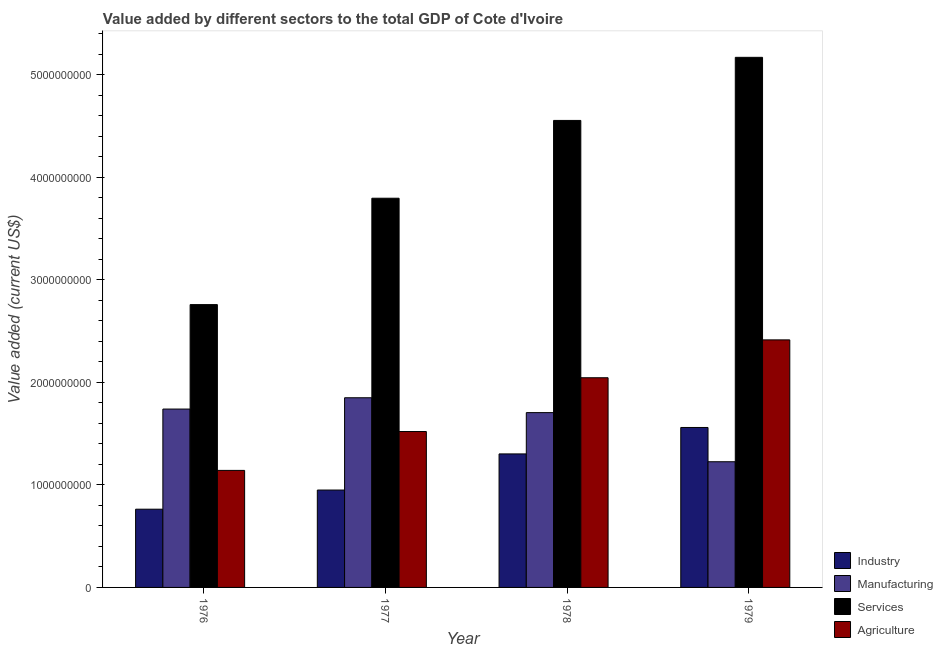How many groups of bars are there?
Your answer should be very brief. 4. How many bars are there on the 3rd tick from the left?
Provide a succinct answer. 4. How many bars are there on the 1st tick from the right?
Your response must be concise. 4. What is the label of the 3rd group of bars from the left?
Offer a terse response. 1978. In how many cases, is the number of bars for a given year not equal to the number of legend labels?
Make the answer very short. 0. What is the value added by services sector in 1978?
Your answer should be compact. 4.55e+09. Across all years, what is the maximum value added by industrial sector?
Offer a very short reply. 1.56e+09. Across all years, what is the minimum value added by manufacturing sector?
Provide a short and direct response. 1.23e+09. In which year was the value added by industrial sector maximum?
Offer a very short reply. 1979. In which year was the value added by industrial sector minimum?
Your answer should be very brief. 1976. What is the total value added by manufacturing sector in the graph?
Provide a succinct answer. 6.52e+09. What is the difference between the value added by industrial sector in 1978 and that in 1979?
Provide a short and direct response. -2.58e+08. What is the difference between the value added by services sector in 1976 and the value added by manufacturing sector in 1978?
Keep it short and to the point. -1.80e+09. What is the average value added by agricultural sector per year?
Give a very brief answer. 1.78e+09. In how many years, is the value added by agricultural sector greater than 4400000000 US$?
Keep it short and to the point. 0. What is the ratio of the value added by agricultural sector in 1976 to that in 1977?
Provide a short and direct response. 0.75. Is the difference between the value added by services sector in 1976 and 1979 greater than the difference between the value added by industrial sector in 1976 and 1979?
Give a very brief answer. No. What is the difference between the highest and the second highest value added by manufacturing sector?
Provide a succinct answer. 1.10e+08. What is the difference between the highest and the lowest value added by industrial sector?
Ensure brevity in your answer.  7.97e+08. In how many years, is the value added by agricultural sector greater than the average value added by agricultural sector taken over all years?
Your response must be concise. 2. Is the sum of the value added by industrial sector in 1977 and 1979 greater than the maximum value added by agricultural sector across all years?
Provide a succinct answer. Yes. What does the 4th bar from the left in 1976 represents?
Provide a short and direct response. Agriculture. What does the 2nd bar from the right in 1977 represents?
Your answer should be very brief. Services. Is it the case that in every year, the sum of the value added by industrial sector and value added by manufacturing sector is greater than the value added by services sector?
Your response must be concise. No. How many bars are there?
Your response must be concise. 16. How many years are there in the graph?
Ensure brevity in your answer.  4. What is the difference between two consecutive major ticks on the Y-axis?
Give a very brief answer. 1.00e+09. Does the graph contain any zero values?
Your answer should be very brief. No. Does the graph contain grids?
Offer a terse response. No. How many legend labels are there?
Offer a terse response. 4. What is the title of the graph?
Provide a short and direct response. Value added by different sectors to the total GDP of Cote d'Ivoire. Does "Quality of logistic services" appear as one of the legend labels in the graph?
Your answer should be very brief. No. What is the label or title of the Y-axis?
Keep it short and to the point. Value added (current US$). What is the Value added (current US$) in Industry in 1976?
Your response must be concise. 7.63e+08. What is the Value added (current US$) of Manufacturing in 1976?
Provide a short and direct response. 1.74e+09. What is the Value added (current US$) of Services in 1976?
Ensure brevity in your answer.  2.76e+09. What is the Value added (current US$) of Agriculture in 1976?
Ensure brevity in your answer.  1.14e+09. What is the Value added (current US$) in Industry in 1977?
Your response must be concise. 9.50e+08. What is the Value added (current US$) in Manufacturing in 1977?
Your answer should be very brief. 1.85e+09. What is the Value added (current US$) in Services in 1977?
Offer a very short reply. 3.80e+09. What is the Value added (current US$) of Agriculture in 1977?
Offer a very short reply. 1.52e+09. What is the Value added (current US$) of Industry in 1978?
Provide a short and direct response. 1.30e+09. What is the Value added (current US$) in Manufacturing in 1978?
Your answer should be compact. 1.70e+09. What is the Value added (current US$) in Services in 1978?
Your answer should be compact. 4.55e+09. What is the Value added (current US$) of Agriculture in 1978?
Provide a succinct answer. 2.04e+09. What is the Value added (current US$) in Industry in 1979?
Keep it short and to the point. 1.56e+09. What is the Value added (current US$) in Manufacturing in 1979?
Your answer should be very brief. 1.23e+09. What is the Value added (current US$) in Services in 1979?
Give a very brief answer. 5.17e+09. What is the Value added (current US$) in Agriculture in 1979?
Make the answer very short. 2.41e+09. Across all years, what is the maximum Value added (current US$) of Industry?
Ensure brevity in your answer.  1.56e+09. Across all years, what is the maximum Value added (current US$) of Manufacturing?
Keep it short and to the point. 1.85e+09. Across all years, what is the maximum Value added (current US$) in Services?
Provide a short and direct response. 5.17e+09. Across all years, what is the maximum Value added (current US$) of Agriculture?
Your answer should be compact. 2.41e+09. Across all years, what is the minimum Value added (current US$) in Industry?
Provide a short and direct response. 7.63e+08. Across all years, what is the minimum Value added (current US$) of Manufacturing?
Give a very brief answer. 1.23e+09. Across all years, what is the minimum Value added (current US$) in Services?
Make the answer very short. 2.76e+09. Across all years, what is the minimum Value added (current US$) in Agriculture?
Provide a succinct answer. 1.14e+09. What is the total Value added (current US$) of Industry in the graph?
Your answer should be compact. 4.57e+09. What is the total Value added (current US$) in Manufacturing in the graph?
Keep it short and to the point. 6.52e+09. What is the total Value added (current US$) of Services in the graph?
Your response must be concise. 1.63e+1. What is the total Value added (current US$) of Agriculture in the graph?
Provide a short and direct response. 7.12e+09. What is the difference between the Value added (current US$) in Industry in 1976 and that in 1977?
Make the answer very short. -1.87e+08. What is the difference between the Value added (current US$) in Manufacturing in 1976 and that in 1977?
Make the answer very short. -1.10e+08. What is the difference between the Value added (current US$) in Services in 1976 and that in 1977?
Give a very brief answer. -1.04e+09. What is the difference between the Value added (current US$) in Agriculture in 1976 and that in 1977?
Your response must be concise. -3.79e+08. What is the difference between the Value added (current US$) in Industry in 1976 and that in 1978?
Keep it short and to the point. -5.39e+08. What is the difference between the Value added (current US$) in Manufacturing in 1976 and that in 1978?
Your response must be concise. 3.48e+07. What is the difference between the Value added (current US$) of Services in 1976 and that in 1978?
Your answer should be compact. -1.80e+09. What is the difference between the Value added (current US$) of Agriculture in 1976 and that in 1978?
Ensure brevity in your answer.  -9.03e+08. What is the difference between the Value added (current US$) in Industry in 1976 and that in 1979?
Give a very brief answer. -7.97e+08. What is the difference between the Value added (current US$) of Manufacturing in 1976 and that in 1979?
Your response must be concise. 5.14e+08. What is the difference between the Value added (current US$) of Services in 1976 and that in 1979?
Provide a succinct answer. -2.41e+09. What is the difference between the Value added (current US$) of Agriculture in 1976 and that in 1979?
Give a very brief answer. -1.27e+09. What is the difference between the Value added (current US$) in Industry in 1977 and that in 1978?
Your response must be concise. -3.52e+08. What is the difference between the Value added (current US$) in Manufacturing in 1977 and that in 1978?
Ensure brevity in your answer.  1.45e+08. What is the difference between the Value added (current US$) in Services in 1977 and that in 1978?
Give a very brief answer. -7.59e+08. What is the difference between the Value added (current US$) of Agriculture in 1977 and that in 1978?
Make the answer very short. -5.24e+08. What is the difference between the Value added (current US$) of Industry in 1977 and that in 1979?
Provide a short and direct response. -6.10e+08. What is the difference between the Value added (current US$) of Manufacturing in 1977 and that in 1979?
Offer a terse response. 6.24e+08. What is the difference between the Value added (current US$) in Services in 1977 and that in 1979?
Make the answer very short. -1.37e+09. What is the difference between the Value added (current US$) of Agriculture in 1977 and that in 1979?
Give a very brief answer. -8.94e+08. What is the difference between the Value added (current US$) in Industry in 1978 and that in 1979?
Offer a very short reply. -2.58e+08. What is the difference between the Value added (current US$) of Manufacturing in 1978 and that in 1979?
Make the answer very short. 4.79e+08. What is the difference between the Value added (current US$) in Services in 1978 and that in 1979?
Your answer should be very brief. -6.15e+08. What is the difference between the Value added (current US$) in Agriculture in 1978 and that in 1979?
Provide a short and direct response. -3.69e+08. What is the difference between the Value added (current US$) in Industry in 1976 and the Value added (current US$) in Manufacturing in 1977?
Provide a succinct answer. -1.09e+09. What is the difference between the Value added (current US$) in Industry in 1976 and the Value added (current US$) in Services in 1977?
Your answer should be very brief. -3.03e+09. What is the difference between the Value added (current US$) of Industry in 1976 and the Value added (current US$) of Agriculture in 1977?
Ensure brevity in your answer.  -7.57e+08. What is the difference between the Value added (current US$) of Manufacturing in 1976 and the Value added (current US$) of Services in 1977?
Ensure brevity in your answer.  -2.06e+09. What is the difference between the Value added (current US$) of Manufacturing in 1976 and the Value added (current US$) of Agriculture in 1977?
Provide a short and direct response. 2.19e+08. What is the difference between the Value added (current US$) of Services in 1976 and the Value added (current US$) of Agriculture in 1977?
Offer a terse response. 1.24e+09. What is the difference between the Value added (current US$) of Industry in 1976 and the Value added (current US$) of Manufacturing in 1978?
Offer a terse response. -9.42e+08. What is the difference between the Value added (current US$) of Industry in 1976 and the Value added (current US$) of Services in 1978?
Your answer should be very brief. -3.79e+09. What is the difference between the Value added (current US$) in Industry in 1976 and the Value added (current US$) in Agriculture in 1978?
Keep it short and to the point. -1.28e+09. What is the difference between the Value added (current US$) in Manufacturing in 1976 and the Value added (current US$) in Services in 1978?
Give a very brief answer. -2.81e+09. What is the difference between the Value added (current US$) in Manufacturing in 1976 and the Value added (current US$) in Agriculture in 1978?
Give a very brief answer. -3.05e+08. What is the difference between the Value added (current US$) of Services in 1976 and the Value added (current US$) of Agriculture in 1978?
Keep it short and to the point. 7.13e+08. What is the difference between the Value added (current US$) of Industry in 1976 and the Value added (current US$) of Manufacturing in 1979?
Offer a very short reply. -4.63e+08. What is the difference between the Value added (current US$) in Industry in 1976 and the Value added (current US$) in Services in 1979?
Offer a terse response. -4.41e+09. What is the difference between the Value added (current US$) of Industry in 1976 and the Value added (current US$) of Agriculture in 1979?
Your answer should be very brief. -1.65e+09. What is the difference between the Value added (current US$) of Manufacturing in 1976 and the Value added (current US$) of Services in 1979?
Keep it short and to the point. -3.43e+09. What is the difference between the Value added (current US$) of Manufacturing in 1976 and the Value added (current US$) of Agriculture in 1979?
Provide a short and direct response. -6.75e+08. What is the difference between the Value added (current US$) in Services in 1976 and the Value added (current US$) in Agriculture in 1979?
Give a very brief answer. 3.44e+08. What is the difference between the Value added (current US$) of Industry in 1977 and the Value added (current US$) of Manufacturing in 1978?
Offer a very short reply. -7.55e+08. What is the difference between the Value added (current US$) of Industry in 1977 and the Value added (current US$) of Services in 1978?
Your response must be concise. -3.60e+09. What is the difference between the Value added (current US$) in Industry in 1977 and the Value added (current US$) in Agriculture in 1978?
Keep it short and to the point. -1.10e+09. What is the difference between the Value added (current US$) of Manufacturing in 1977 and the Value added (current US$) of Services in 1978?
Give a very brief answer. -2.70e+09. What is the difference between the Value added (current US$) of Manufacturing in 1977 and the Value added (current US$) of Agriculture in 1978?
Your response must be concise. -1.95e+08. What is the difference between the Value added (current US$) of Services in 1977 and the Value added (current US$) of Agriculture in 1978?
Keep it short and to the point. 1.75e+09. What is the difference between the Value added (current US$) of Industry in 1977 and the Value added (current US$) of Manufacturing in 1979?
Ensure brevity in your answer.  -2.76e+08. What is the difference between the Value added (current US$) in Industry in 1977 and the Value added (current US$) in Services in 1979?
Provide a succinct answer. -4.22e+09. What is the difference between the Value added (current US$) in Industry in 1977 and the Value added (current US$) in Agriculture in 1979?
Provide a succinct answer. -1.46e+09. What is the difference between the Value added (current US$) of Manufacturing in 1977 and the Value added (current US$) of Services in 1979?
Offer a very short reply. -3.32e+09. What is the difference between the Value added (current US$) in Manufacturing in 1977 and the Value added (current US$) in Agriculture in 1979?
Your response must be concise. -5.64e+08. What is the difference between the Value added (current US$) in Services in 1977 and the Value added (current US$) in Agriculture in 1979?
Your answer should be compact. 1.38e+09. What is the difference between the Value added (current US$) in Industry in 1978 and the Value added (current US$) in Manufacturing in 1979?
Make the answer very short. 7.64e+07. What is the difference between the Value added (current US$) in Industry in 1978 and the Value added (current US$) in Services in 1979?
Your answer should be compact. -3.87e+09. What is the difference between the Value added (current US$) of Industry in 1978 and the Value added (current US$) of Agriculture in 1979?
Give a very brief answer. -1.11e+09. What is the difference between the Value added (current US$) in Manufacturing in 1978 and the Value added (current US$) in Services in 1979?
Provide a succinct answer. -3.46e+09. What is the difference between the Value added (current US$) of Manufacturing in 1978 and the Value added (current US$) of Agriculture in 1979?
Ensure brevity in your answer.  -7.09e+08. What is the difference between the Value added (current US$) of Services in 1978 and the Value added (current US$) of Agriculture in 1979?
Provide a short and direct response. 2.14e+09. What is the average Value added (current US$) of Industry per year?
Make the answer very short. 1.14e+09. What is the average Value added (current US$) in Manufacturing per year?
Provide a succinct answer. 1.63e+09. What is the average Value added (current US$) of Services per year?
Offer a terse response. 4.07e+09. What is the average Value added (current US$) in Agriculture per year?
Provide a short and direct response. 1.78e+09. In the year 1976, what is the difference between the Value added (current US$) in Industry and Value added (current US$) in Manufacturing?
Your answer should be very brief. -9.77e+08. In the year 1976, what is the difference between the Value added (current US$) in Industry and Value added (current US$) in Services?
Offer a terse response. -1.99e+09. In the year 1976, what is the difference between the Value added (current US$) of Industry and Value added (current US$) of Agriculture?
Your response must be concise. -3.78e+08. In the year 1976, what is the difference between the Value added (current US$) of Manufacturing and Value added (current US$) of Services?
Make the answer very short. -1.02e+09. In the year 1976, what is the difference between the Value added (current US$) in Manufacturing and Value added (current US$) in Agriculture?
Provide a succinct answer. 5.98e+08. In the year 1976, what is the difference between the Value added (current US$) in Services and Value added (current US$) in Agriculture?
Your answer should be compact. 1.62e+09. In the year 1977, what is the difference between the Value added (current US$) in Industry and Value added (current US$) in Manufacturing?
Your answer should be very brief. -9.00e+08. In the year 1977, what is the difference between the Value added (current US$) in Industry and Value added (current US$) in Services?
Your answer should be compact. -2.85e+09. In the year 1977, what is the difference between the Value added (current US$) of Industry and Value added (current US$) of Agriculture?
Your answer should be compact. -5.71e+08. In the year 1977, what is the difference between the Value added (current US$) of Manufacturing and Value added (current US$) of Services?
Your answer should be compact. -1.95e+09. In the year 1977, what is the difference between the Value added (current US$) in Manufacturing and Value added (current US$) in Agriculture?
Offer a very short reply. 3.29e+08. In the year 1977, what is the difference between the Value added (current US$) of Services and Value added (current US$) of Agriculture?
Offer a very short reply. 2.27e+09. In the year 1978, what is the difference between the Value added (current US$) of Industry and Value added (current US$) of Manufacturing?
Offer a very short reply. -4.03e+08. In the year 1978, what is the difference between the Value added (current US$) of Industry and Value added (current US$) of Services?
Make the answer very short. -3.25e+09. In the year 1978, what is the difference between the Value added (current US$) in Industry and Value added (current US$) in Agriculture?
Give a very brief answer. -7.43e+08. In the year 1978, what is the difference between the Value added (current US$) of Manufacturing and Value added (current US$) of Services?
Keep it short and to the point. -2.85e+09. In the year 1978, what is the difference between the Value added (current US$) of Manufacturing and Value added (current US$) of Agriculture?
Give a very brief answer. -3.40e+08. In the year 1978, what is the difference between the Value added (current US$) in Services and Value added (current US$) in Agriculture?
Provide a short and direct response. 2.51e+09. In the year 1979, what is the difference between the Value added (current US$) of Industry and Value added (current US$) of Manufacturing?
Provide a succinct answer. 3.34e+08. In the year 1979, what is the difference between the Value added (current US$) in Industry and Value added (current US$) in Services?
Offer a very short reply. -3.61e+09. In the year 1979, what is the difference between the Value added (current US$) in Industry and Value added (current US$) in Agriculture?
Your answer should be compact. -8.54e+08. In the year 1979, what is the difference between the Value added (current US$) in Manufacturing and Value added (current US$) in Services?
Give a very brief answer. -3.94e+09. In the year 1979, what is the difference between the Value added (current US$) of Manufacturing and Value added (current US$) of Agriculture?
Offer a very short reply. -1.19e+09. In the year 1979, what is the difference between the Value added (current US$) in Services and Value added (current US$) in Agriculture?
Your answer should be very brief. 2.76e+09. What is the ratio of the Value added (current US$) of Industry in 1976 to that in 1977?
Give a very brief answer. 0.8. What is the ratio of the Value added (current US$) of Manufacturing in 1976 to that in 1977?
Offer a very short reply. 0.94. What is the ratio of the Value added (current US$) of Services in 1976 to that in 1977?
Offer a terse response. 0.73. What is the ratio of the Value added (current US$) of Agriculture in 1976 to that in 1977?
Provide a succinct answer. 0.75. What is the ratio of the Value added (current US$) in Industry in 1976 to that in 1978?
Ensure brevity in your answer.  0.59. What is the ratio of the Value added (current US$) of Manufacturing in 1976 to that in 1978?
Provide a succinct answer. 1.02. What is the ratio of the Value added (current US$) in Services in 1976 to that in 1978?
Keep it short and to the point. 0.61. What is the ratio of the Value added (current US$) in Agriculture in 1976 to that in 1978?
Offer a very short reply. 0.56. What is the ratio of the Value added (current US$) in Industry in 1976 to that in 1979?
Your answer should be compact. 0.49. What is the ratio of the Value added (current US$) of Manufacturing in 1976 to that in 1979?
Make the answer very short. 1.42. What is the ratio of the Value added (current US$) of Services in 1976 to that in 1979?
Give a very brief answer. 0.53. What is the ratio of the Value added (current US$) in Agriculture in 1976 to that in 1979?
Ensure brevity in your answer.  0.47. What is the ratio of the Value added (current US$) of Industry in 1977 to that in 1978?
Offer a very short reply. 0.73. What is the ratio of the Value added (current US$) in Manufacturing in 1977 to that in 1978?
Ensure brevity in your answer.  1.08. What is the ratio of the Value added (current US$) of Services in 1977 to that in 1978?
Your answer should be compact. 0.83. What is the ratio of the Value added (current US$) in Agriculture in 1977 to that in 1978?
Your answer should be very brief. 0.74. What is the ratio of the Value added (current US$) in Industry in 1977 to that in 1979?
Provide a succinct answer. 0.61. What is the ratio of the Value added (current US$) in Manufacturing in 1977 to that in 1979?
Your answer should be very brief. 1.51. What is the ratio of the Value added (current US$) in Services in 1977 to that in 1979?
Your response must be concise. 0.73. What is the ratio of the Value added (current US$) in Agriculture in 1977 to that in 1979?
Provide a succinct answer. 0.63. What is the ratio of the Value added (current US$) of Industry in 1978 to that in 1979?
Keep it short and to the point. 0.83. What is the ratio of the Value added (current US$) in Manufacturing in 1978 to that in 1979?
Provide a short and direct response. 1.39. What is the ratio of the Value added (current US$) in Services in 1978 to that in 1979?
Your answer should be compact. 0.88. What is the ratio of the Value added (current US$) of Agriculture in 1978 to that in 1979?
Offer a very short reply. 0.85. What is the difference between the highest and the second highest Value added (current US$) in Industry?
Keep it short and to the point. 2.58e+08. What is the difference between the highest and the second highest Value added (current US$) of Manufacturing?
Provide a short and direct response. 1.10e+08. What is the difference between the highest and the second highest Value added (current US$) of Services?
Your answer should be very brief. 6.15e+08. What is the difference between the highest and the second highest Value added (current US$) of Agriculture?
Make the answer very short. 3.69e+08. What is the difference between the highest and the lowest Value added (current US$) of Industry?
Provide a short and direct response. 7.97e+08. What is the difference between the highest and the lowest Value added (current US$) in Manufacturing?
Provide a succinct answer. 6.24e+08. What is the difference between the highest and the lowest Value added (current US$) of Services?
Give a very brief answer. 2.41e+09. What is the difference between the highest and the lowest Value added (current US$) in Agriculture?
Provide a short and direct response. 1.27e+09. 